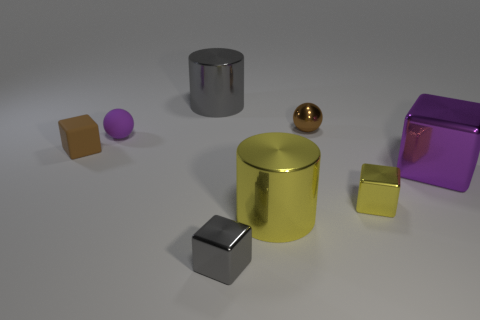Subtract all brown cubes. How many cubes are left? 3 Subtract all small yellow blocks. How many blocks are left? 3 Subtract all cyan blocks. Subtract all green cylinders. How many blocks are left? 4 Add 1 tiny cyan matte things. How many objects exist? 9 Subtract all cylinders. How many objects are left? 6 Add 4 large blocks. How many large blocks are left? 5 Add 8 purple metal objects. How many purple metal objects exist? 9 Subtract 0 purple cylinders. How many objects are left? 8 Subtract all yellow metallic things. Subtract all large purple metallic blocks. How many objects are left? 5 